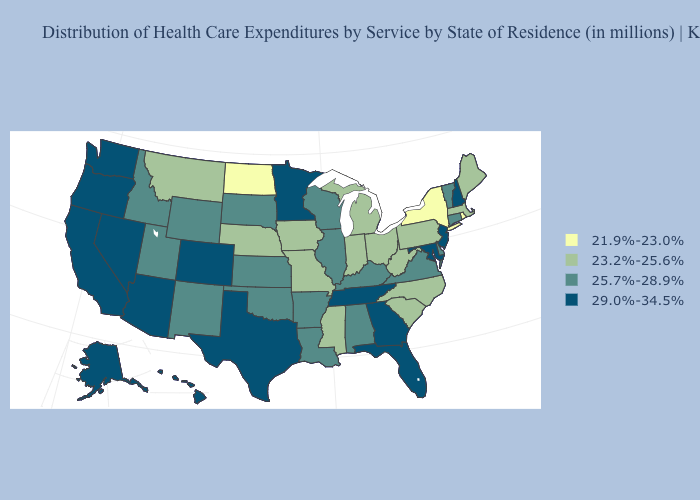Name the states that have a value in the range 23.2%-25.6%?
Give a very brief answer. Indiana, Iowa, Maine, Massachusetts, Michigan, Mississippi, Missouri, Montana, Nebraska, North Carolina, Ohio, Pennsylvania, South Carolina, West Virginia. Does Minnesota have the same value as Georgia?
Be succinct. Yes. Does Georgia have the highest value in the South?
Be succinct. Yes. Is the legend a continuous bar?
Keep it brief. No. Does Pennsylvania have a higher value than Michigan?
Short answer required. No. Name the states that have a value in the range 25.7%-28.9%?
Concise answer only. Alabama, Arkansas, Connecticut, Delaware, Idaho, Illinois, Kansas, Kentucky, Louisiana, New Mexico, Oklahoma, South Dakota, Utah, Vermont, Virginia, Wisconsin, Wyoming. Name the states that have a value in the range 21.9%-23.0%?
Short answer required. New York, North Dakota, Rhode Island. Name the states that have a value in the range 25.7%-28.9%?
Give a very brief answer. Alabama, Arkansas, Connecticut, Delaware, Idaho, Illinois, Kansas, Kentucky, Louisiana, New Mexico, Oklahoma, South Dakota, Utah, Vermont, Virginia, Wisconsin, Wyoming. What is the value of Virginia?
Keep it brief. 25.7%-28.9%. What is the value of Tennessee?
Write a very short answer. 29.0%-34.5%. Does the map have missing data?
Concise answer only. No. Name the states that have a value in the range 29.0%-34.5%?
Answer briefly. Alaska, Arizona, California, Colorado, Florida, Georgia, Hawaii, Maryland, Minnesota, Nevada, New Hampshire, New Jersey, Oregon, Tennessee, Texas, Washington. Does North Dakota have the lowest value in the USA?
Short answer required. Yes. Among the states that border Pennsylvania , does New York have the lowest value?
Answer briefly. Yes. Which states have the highest value in the USA?
Answer briefly. Alaska, Arizona, California, Colorado, Florida, Georgia, Hawaii, Maryland, Minnesota, Nevada, New Hampshire, New Jersey, Oregon, Tennessee, Texas, Washington. 